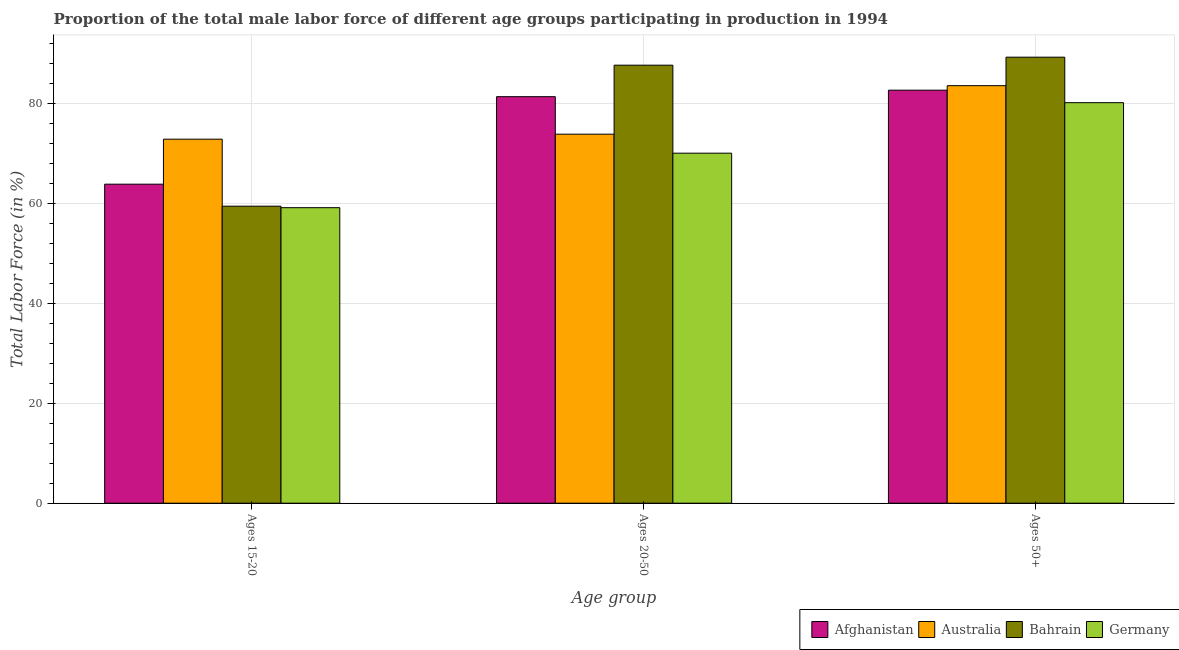How many groups of bars are there?
Ensure brevity in your answer.  3. Are the number of bars per tick equal to the number of legend labels?
Your response must be concise. Yes. How many bars are there on the 2nd tick from the right?
Ensure brevity in your answer.  4. What is the label of the 2nd group of bars from the left?
Your response must be concise. Ages 20-50. What is the percentage of male labor force within the age group 15-20 in Afghanistan?
Keep it short and to the point. 63.8. Across all countries, what is the maximum percentage of male labor force within the age group 20-50?
Provide a short and direct response. 87.6. Across all countries, what is the minimum percentage of male labor force above age 50?
Keep it short and to the point. 80.1. In which country was the percentage of male labor force within the age group 15-20 maximum?
Make the answer very short. Australia. What is the total percentage of male labor force within the age group 15-20 in the graph?
Give a very brief answer. 255.1. What is the difference between the percentage of male labor force within the age group 20-50 in Australia and that in Afghanistan?
Offer a terse response. -7.5. What is the difference between the percentage of male labor force within the age group 15-20 in Afghanistan and the percentage of male labor force within the age group 20-50 in Germany?
Your response must be concise. -6.2. What is the average percentage of male labor force above age 50 per country?
Offer a terse response. 83.85. What is the difference between the percentage of male labor force above age 50 and percentage of male labor force within the age group 15-20 in Australia?
Make the answer very short. 10.7. In how many countries, is the percentage of male labor force within the age group 20-50 greater than 20 %?
Offer a very short reply. 4. What is the ratio of the percentage of male labor force within the age group 15-20 in Germany to that in Australia?
Your answer should be very brief. 0.81. Is the percentage of male labor force within the age group 20-50 in Afghanistan less than that in Germany?
Provide a short and direct response. No. Is the difference between the percentage of male labor force within the age group 15-20 in Bahrain and Germany greater than the difference between the percentage of male labor force above age 50 in Bahrain and Germany?
Provide a short and direct response. No. What is the difference between the highest and the second highest percentage of male labor force within the age group 20-50?
Make the answer very short. 6.3. What is the difference between the highest and the lowest percentage of male labor force within the age group 20-50?
Your answer should be compact. 17.6. In how many countries, is the percentage of male labor force within the age group 20-50 greater than the average percentage of male labor force within the age group 20-50 taken over all countries?
Provide a succinct answer. 2. Is the sum of the percentage of male labor force above age 50 in Germany and Afghanistan greater than the maximum percentage of male labor force within the age group 15-20 across all countries?
Offer a terse response. Yes. What does the 3rd bar from the left in Ages 15-20 represents?
Ensure brevity in your answer.  Bahrain. What does the 2nd bar from the right in Ages 50+ represents?
Keep it short and to the point. Bahrain. Is it the case that in every country, the sum of the percentage of male labor force within the age group 15-20 and percentage of male labor force within the age group 20-50 is greater than the percentage of male labor force above age 50?
Provide a succinct answer. Yes. How many bars are there?
Make the answer very short. 12. Are all the bars in the graph horizontal?
Provide a short and direct response. No. What is the difference between two consecutive major ticks on the Y-axis?
Your answer should be compact. 20. Are the values on the major ticks of Y-axis written in scientific E-notation?
Provide a succinct answer. No. How are the legend labels stacked?
Offer a terse response. Horizontal. What is the title of the graph?
Keep it short and to the point. Proportion of the total male labor force of different age groups participating in production in 1994. What is the label or title of the X-axis?
Your answer should be compact. Age group. What is the label or title of the Y-axis?
Your response must be concise. Total Labor Force (in %). What is the Total Labor Force (in %) of Afghanistan in Ages 15-20?
Your answer should be compact. 63.8. What is the Total Labor Force (in %) in Australia in Ages 15-20?
Ensure brevity in your answer.  72.8. What is the Total Labor Force (in %) in Bahrain in Ages 15-20?
Keep it short and to the point. 59.4. What is the Total Labor Force (in %) of Germany in Ages 15-20?
Provide a short and direct response. 59.1. What is the Total Labor Force (in %) in Afghanistan in Ages 20-50?
Offer a terse response. 81.3. What is the Total Labor Force (in %) of Australia in Ages 20-50?
Your answer should be very brief. 73.8. What is the Total Labor Force (in %) in Bahrain in Ages 20-50?
Offer a terse response. 87.6. What is the Total Labor Force (in %) of Afghanistan in Ages 50+?
Provide a succinct answer. 82.6. What is the Total Labor Force (in %) of Australia in Ages 50+?
Your response must be concise. 83.5. What is the Total Labor Force (in %) in Bahrain in Ages 50+?
Your answer should be compact. 89.2. What is the Total Labor Force (in %) of Germany in Ages 50+?
Your answer should be very brief. 80.1. Across all Age group, what is the maximum Total Labor Force (in %) in Afghanistan?
Keep it short and to the point. 82.6. Across all Age group, what is the maximum Total Labor Force (in %) in Australia?
Keep it short and to the point. 83.5. Across all Age group, what is the maximum Total Labor Force (in %) of Bahrain?
Your answer should be very brief. 89.2. Across all Age group, what is the maximum Total Labor Force (in %) in Germany?
Provide a short and direct response. 80.1. Across all Age group, what is the minimum Total Labor Force (in %) in Afghanistan?
Give a very brief answer. 63.8. Across all Age group, what is the minimum Total Labor Force (in %) in Australia?
Offer a very short reply. 72.8. Across all Age group, what is the minimum Total Labor Force (in %) of Bahrain?
Give a very brief answer. 59.4. Across all Age group, what is the minimum Total Labor Force (in %) of Germany?
Make the answer very short. 59.1. What is the total Total Labor Force (in %) in Afghanistan in the graph?
Make the answer very short. 227.7. What is the total Total Labor Force (in %) of Australia in the graph?
Provide a succinct answer. 230.1. What is the total Total Labor Force (in %) of Bahrain in the graph?
Keep it short and to the point. 236.2. What is the total Total Labor Force (in %) of Germany in the graph?
Give a very brief answer. 209.2. What is the difference between the Total Labor Force (in %) of Afghanistan in Ages 15-20 and that in Ages 20-50?
Offer a terse response. -17.5. What is the difference between the Total Labor Force (in %) of Australia in Ages 15-20 and that in Ages 20-50?
Offer a terse response. -1. What is the difference between the Total Labor Force (in %) of Bahrain in Ages 15-20 and that in Ages 20-50?
Your answer should be very brief. -28.2. What is the difference between the Total Labor Force (in %) in Germany in Ages 15-20 and that in Ages 20-50?
Make the answer very short. -10.9. What is the difference between the Total Labor Force (in %) in Afghanistan in Ages 15-20 and that in Ages 50+?
Offer a very short reply. -18.8. What is the difference between the Total Labor Force (in %) in Bahrain in Ages 15-20 and that in Ages 50+?
Offer a very short reply. -29.8. What is the difference between the Total Labor Force (in %) in Germany in Ages 15-20 and that in Ages 50+?
Provide a succinct answer. -21. What is the difference between the Total Labor Force (in %) in Afghanistan in Ages 20-50 and that in Ages 50+?
Provide a short and direct response. -1.3. What is the difference between the Total Labor Force (in %) in Australia in Ages 20-50 and that in Ages 50+?
Your answer should be compact. -9.7. What is the difference between the Total Labor Force (in %) of Bahrain in Ages 20-50 and that in Ages 50+?
Offer a terse response. -1.6. What is the difference between the Total Labor Force (in %) of Afghanistan in Ages 15-20 and the Total Labor Force (in %) of Australia in Ages 20-50?
Offer a very short reply. -10. What is the difference between the Total Labor Force (in %) in Afghanistan in Ages 15-20 and the Total Labor Force (in %) in Bahrain in Ages 20-50?
Keep it short and to the point. -23.8. What is the difference between the Total Labor Force (in %) of Australia in Ages 15-20 and the Total Labor Force (in %) of Bahrain in Ages 20-50?
Your answer should be very brief. -14.8. What is the difference between the Total Labor Force (in %) of Afghanistan in Ages 15-20 and the Total Labor Force (in %) of Australia in Ages 50+?
Give a very brief answer. -19.7. What is the difference between the Total Labor Force (in %) of Afghanistan in Ages 15-20 and the Total Labor Force (in %) of Bahrain in Ages 50+?
Your answer should be very brief. -25.4. What is the difference between the Total Labor Force (in %) of Afghanistan in Ages 15-20 and the Total Labor Force (in %) of Germany in Ages 50+?
Provide a succinct answer. -16.3. What is the difference between the Total Labor Force (in %) of Australia in Ages 15-20 and the Total Labor Force (in %) of Bahrain in Ages 50+?
Your answer should be compact. -16.4. What is the difference between the Total Labor Force (in %) of Australia in Ages 15-20 and the Total Labor Force (in %) of Germany in Ages 50+?
Offer a very short reply. -7.3. What is the difference between the Total Labor Force (in %) in Bahrain in Ages 15-20 and the Total Labor Force (in %) in Germany in Ages 50+?
Keep it short and to the point. -20.7. What is the difference between the Total Labor Force (in %) of Afghanistan in Ages 20-50 and the Total Labor Force (in %) of Australia in Ages 50+?
Make the answer very short. -2.2. What is the difference between the Total Labor Force (in %) in Afghanistan in Ages 20-50 and the Total Labor Force (in %) in Bahrain in Ages 50+?
Make the answer very short. -7.9. What is the difference between the Total Labor Force (in %) in Australia in Ages 20-50 and the Total Labor Force (in %) in Bahrain in Ages 50+?
Your response must be concise. -15.4. What is the difference between the Total Labor Force (in %) in Bahrain in Ages 20-50 and the Total Labor Force (in %) in Germany in Ages 50+?
Your answer should be compact. 7.5. What is the average Total Labor Force (in %) of Afghanistan per Age group?
Offer a very short reply. 75.9. What is the average Total Labor Force (in %) in Australia per Age group?
Your answer should be compact. 76.7. What is the average Total Labor Force (in %) of Bahrain per Age group?
Provide a short and direct response. 78.73. What is the average Total Labor Force (in %) in Germany per Age group?
Give a very brief answer. 69.73. What is the difference between the Total Labor Force (in %) in Afghanistan and Total Labor Force (in %) in Bahrain in Ages 15-20?
Your answer should be compact. 4.4. What is the difference between the Total Labor Force (in %) in Australia and Total Labor Force (in %) in Bahrain in Ages 15-20?
Give a very brief answer. 13.4. What is the difference between the Total Labor Force (in %) of Bahrain and Total Labor Force (in %) of Germany in Ages 15-20?
Make the answer very short. 0.3. What is the difference between the Total Labor Force (in %) of Afghanistan and Total Labor Force (in %) of Australia in Ages 20-50?
Keep it short and to the point. 7.5. What is the difference between the Total Labor Force (in %) of Afghanistan and Total Labor Force (in %) of Germany in Ages 20-50?
Your answer should be very brief. 11.3. What is the difference between the Total Labor Force (in %) in Australia and Total Labor Force (in %) in Germany in Ages 20-50?
Offer a very short reply. 3.8. What is the difference between the Total Labor Force (in %) in Afghanistan and Total Labor Force (in %) in Germany in Ages 50+?
Your answer should be very brief. 2.5. What is the difference between the Total Labor Force (in %) in Australia and Total Labor Force (in %) in Bahrain in Ages 50+?
Provide a succinct answer. -5.7. What is the difference between the Total Labor Force (in %) of Australia and Total Labor Force (in %) of Germany in Ages 50+?
Your response must be concise. 3.4. What is the ratio of the Total Labor Force (in %) of Afghanistan in Ages 15-20 to that in Ages 20-50?
Your answer should be compact. 0.78. What is the ratio of the Total Labor Force (in %) of Australia in Ages 15-20 to that in Ages 20-50?
Offer a terse response. 0.99. What is the ratio of the Total Labor Force (in %) of Bahrain in Ages 15-20 to that in Ages 20-50?
Your answer should be very brief. 0.68. What is the ratio of the Total Labor Force (in %) of Germany in Ages 15-20 to that in Ages 20-50?
Offer a terse response. 0.84. What is the ratio of the Total Labor Force (in %) in Afghanistan in Ages 15-20 to that in Ages 50+?
Keep it short and to the point. 0.77. What is the ratio of the Total Labor Force (in %) of Australia in Ages 15-20 to that in Ages 50+?
Your answer should be compact. 0.87. What is the ratio of the Total Labor Force (in %) in Bahrain in Ages 15-20 to that in Ages 50+?
Your answer should be very brief. 0.67. What is the ratio of the Total Labor Force (in %) of Germany in Ages 15-20 to that in Ages 50+?
Your answer should be compact. 0.74. What is the ratio of the Total Labor Force (in %) of Afghanistan in Ages 20-50 to that in Ages 50+?
Your answer should be very brief. 0.98. What is the ratio of the Total Labor Force (in %) of Australia in Ages 20-50 to that in Ages 50+?
Ensure brevity in your answer.  0.88. What is the ratio of the Total Labor Force (in %) in Bahrain in Ages 20-50 to that in Ages 50+?
Offer a very short reply. 0.98. What is the ratio of the Total Labor Force (in %) of Germany in Ages 20-50 to that in Ages 50+?
Provide a succinct answer. 0.87. What is the difference between the highest and the second highest Total Labor Force (in %) of Afghanistan?
Your answer should be compact. 1.3. What is the difference between the highest and the second highest Total Labor Force (in %) in Bahrain?
Provide a short and direct response. 1.6. What is the difference between the highest and the second highest Total Labor Force (in %) of Germany?
Provide a short and direct response. 10.1. What is the difference between the highest and the lowest Total Labor Force (in %) of Afghanistan?
Provide a succinct answer. 18.8. What is the difference between the highest and the lowest Total Labor Force (in %) in Bahrain?
Your answer should be compact. 29.8. What is the difference between the highest and the lowest Total Labor Force (in %) of Germany?
Keep it short and to the point. 21. 